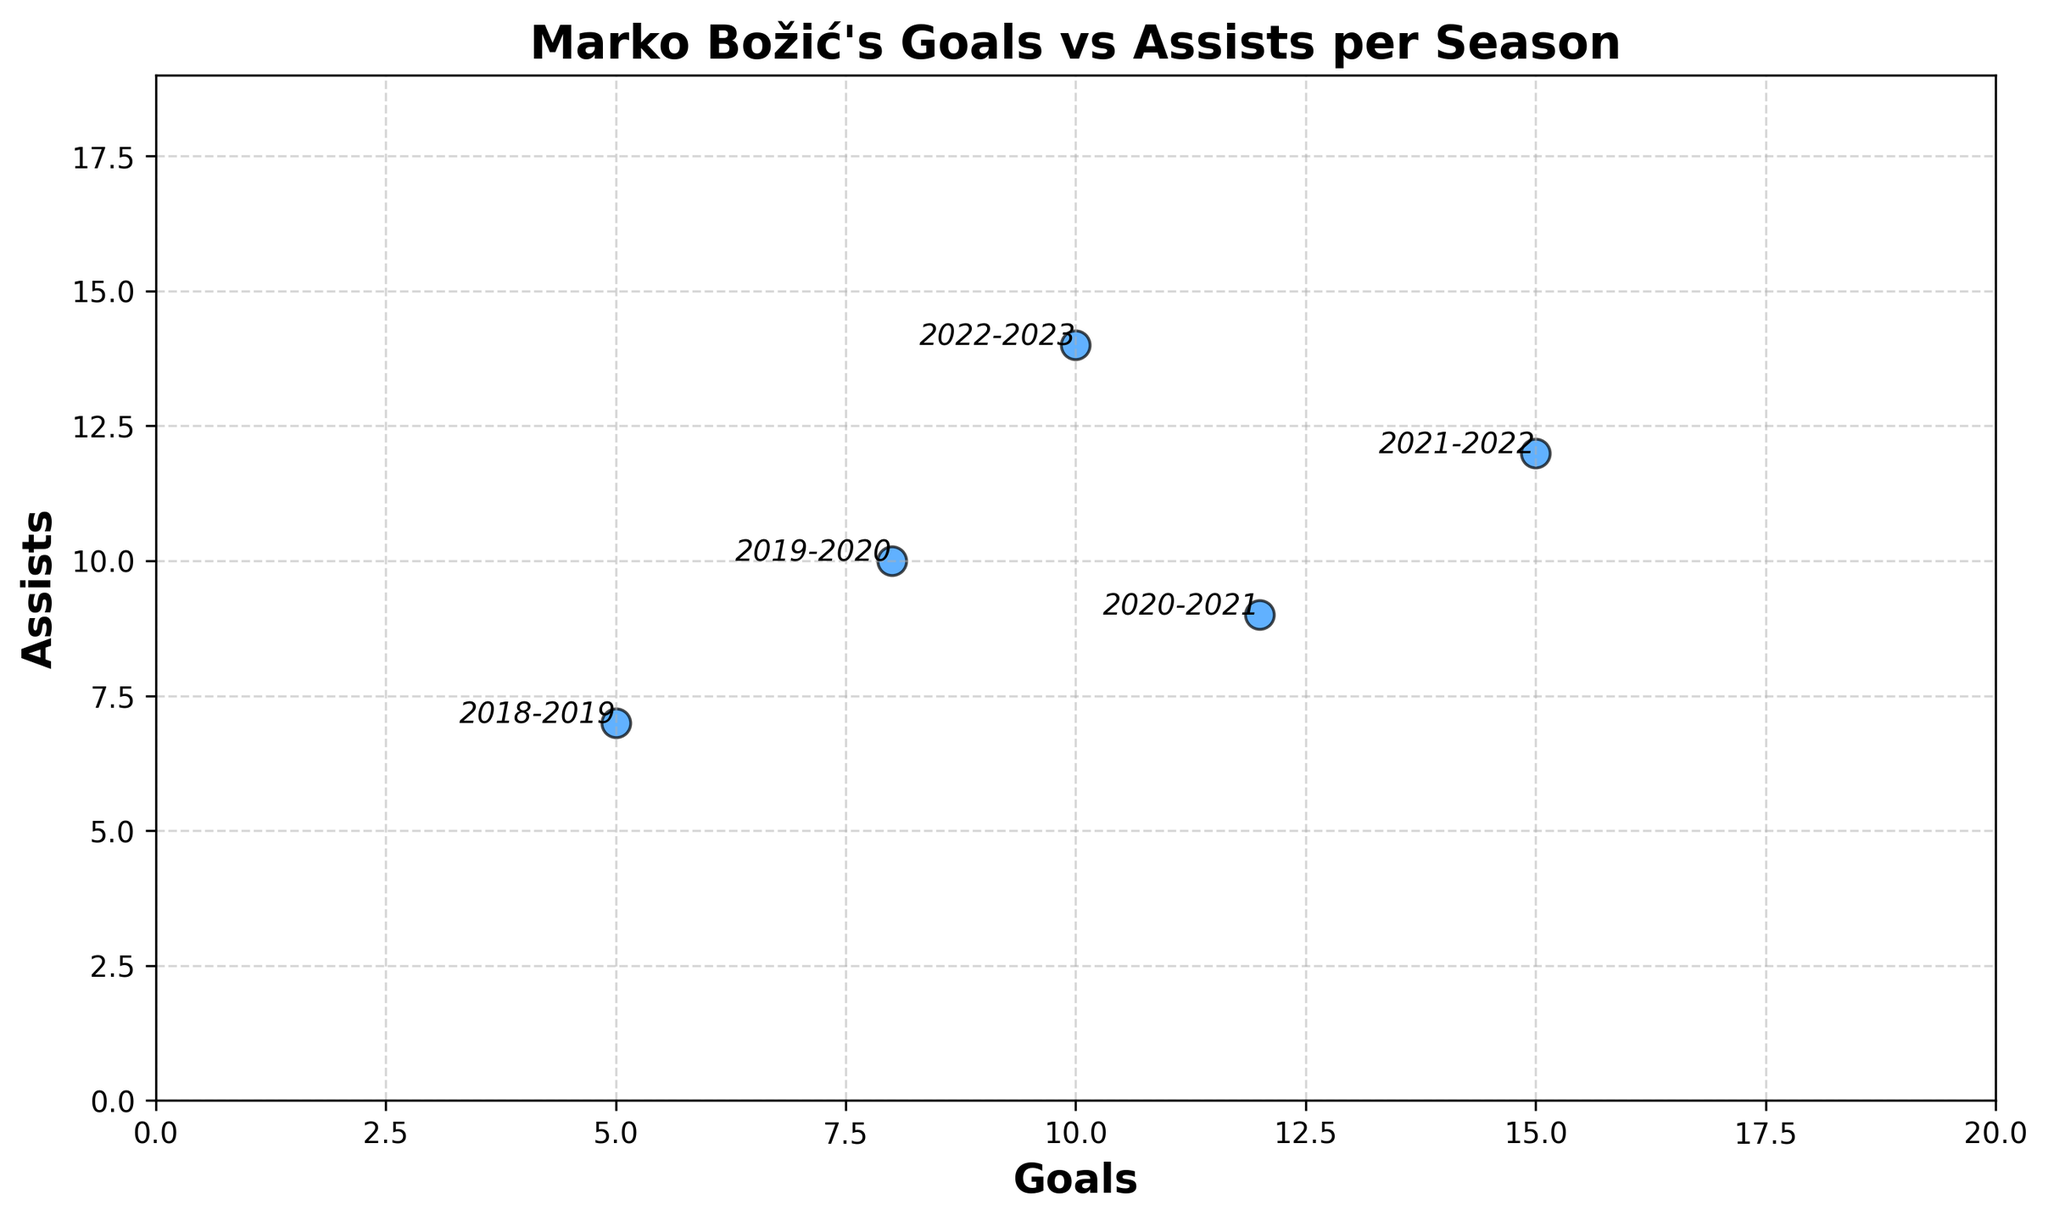What is the trend for Marko Božić's goals from the 2018-2019 season to the 2022-2023 season? The scatter plot shows that goals generally increased from 5 in the 2018-2019 season to a peak of 15 in the 2021-2022 season, followed by a decline to 10 goals in the 2022-2023 season.
Answer: Goals increased from 2018-2022, then decreased in 2022-2023 Which season had the highest number of assists? Observing the scatter plot, the point highest on the y-axis, marked "2022-2023," indicates that the 2022-2023 season had the most assists, with a total of 14.
Answer: 2022-2023 Which season had an equal number of goals and assists? Looking at the plotted points, no season's goals and assists values are equal; each season's goals and assists values are distinct.
Answer: None Compare the goals and assists in the 2020-2021 season. Which was greater? By identifying the point tagged "2020-2021," we see that goals (12) are greater than assists (9).
Answer: Goals were greater Is there any season where the increase in goals from the previous season was greater than the increase in assists? If yes, name the season. Comparing the difference between successive seasons: From 2018-2019 to 2019-2020, goals increased by 3 and assists by 3. From 2019-2020 to 2020-2021, goals increased by 4 and assists decreased by 1. Remaining seasons follow other patterns. So, only the 2020-2021 season fits this pattern.
Answer: 2020-2021 What is the average number of goals scored by Marko Božić across the five seasons represented in the scatter plot? Sum of goals (5 + 8 + 12 + 15 + 10) divided by the number of seasons (5). The total is 50, so the average is 50/5 = 10.
Answer: 10 Which season had the smallest difference between the number of goals and assists? What is the difference? Calculate the difference for each season: 
2018-2019: 7 - 5 = 2, 
2019-2020: 10 - 8 = 2, 
2020-2021: 12 - 9 = 3, 
2021-2022: 15 - 12 = 3, 
2022-2023: 14 - 10 = 4. The smallest differences are in the 2018-2019 and 2019-2020 seasons, both at 2.
Answer: Two seasons (2018-2019, 2019-2020) had a difference of 2 Across all seasons, what is the total number of assists made by Marko Božić? Sum the assists: 7 + 10 + 9 + 12 + 14 = 52.
Answer: 52 If you were to visualize the goals and assists on a line plot, how would the lines for goals and assists compare over the seasons? The line for goals would start lower and generally ascend, peaking in 2021-2022 before dropping in 2022-2023. The line for assists would also trend upwards but less steeply, peaking in 2022-2023, showing a more consistent increase.
Answer: Both lines ascend, goals peak mid-way, assists peak at the end Comparing the seasons 2019-2020 and 2020-2021, did the relationship between goals and assists change significantly? Comparing the points: 2019-2020 (goals 8, assists 10) and 2020-2021 (goals 12, assists 9). There was a significant increase in goals and a slight decrease in assists.
Answer: Yes, significant increase in goals, minor decrease in assists 